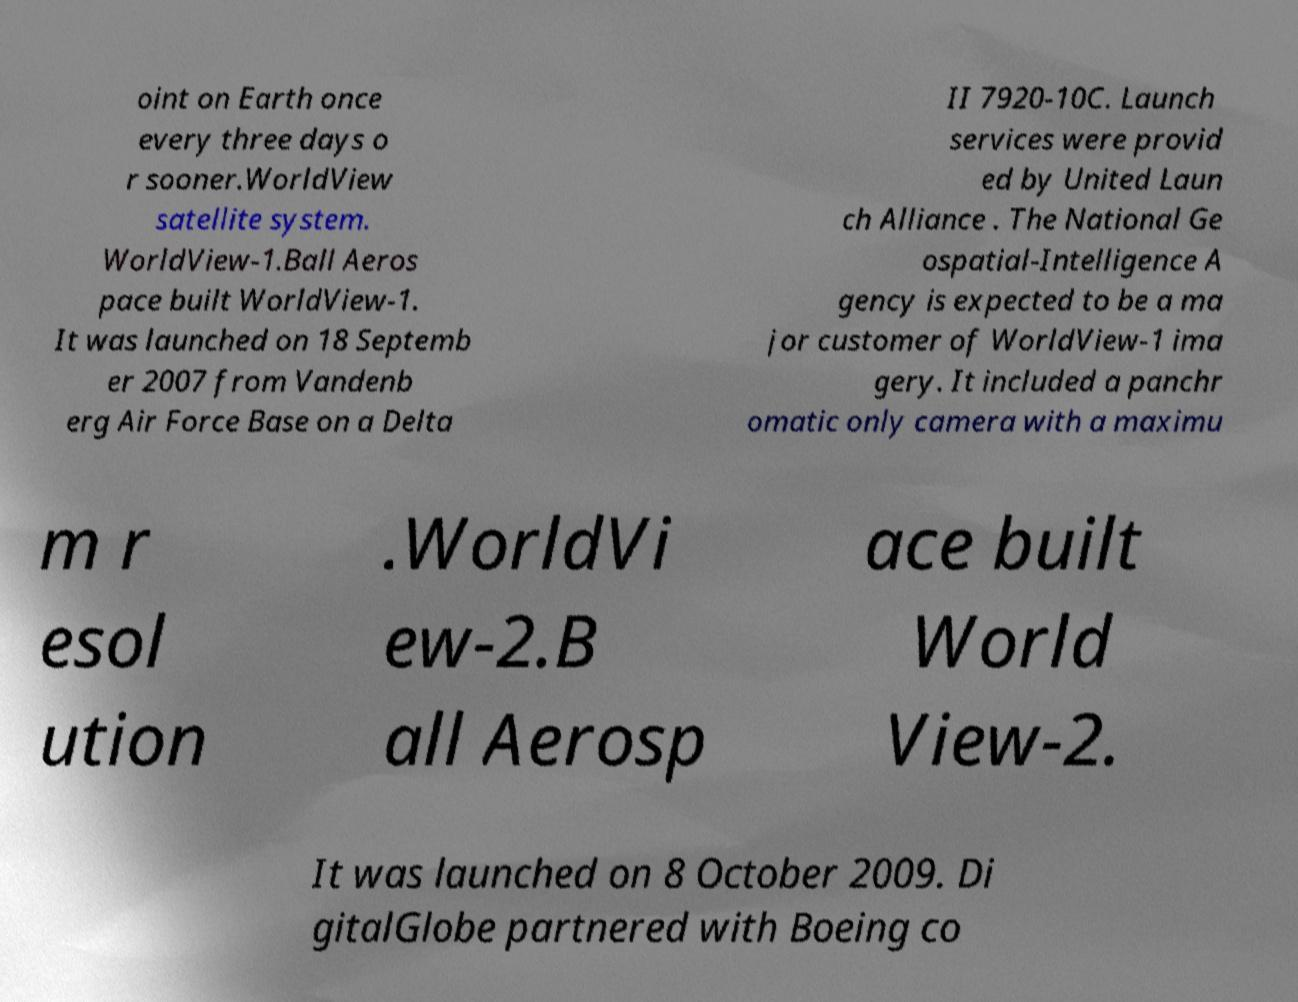Could you extract and type out the text from this image? oint on Earth once every three days o r sooner.WorldView satellite system. WorldView-1.Ball Aeros pace built WorldView-1. It was launched on 18 Septemb er 2007 from Vandenb erg Air Force Base on a Delta II 7920-10C. Launch services were provid ed by United Laun ch Alliance . The National Ge ospatial-Intelligence A gency is expected to be a ma jor customer of WorldView-1 ima gery. It included a panchr omatic only camera with a maximu m r esol ution .WorldVi ew-2.B all Aerosp ace built World View-2. It was launched on 8 October 2009. Di gitalGlobe partnered with Boeing co 